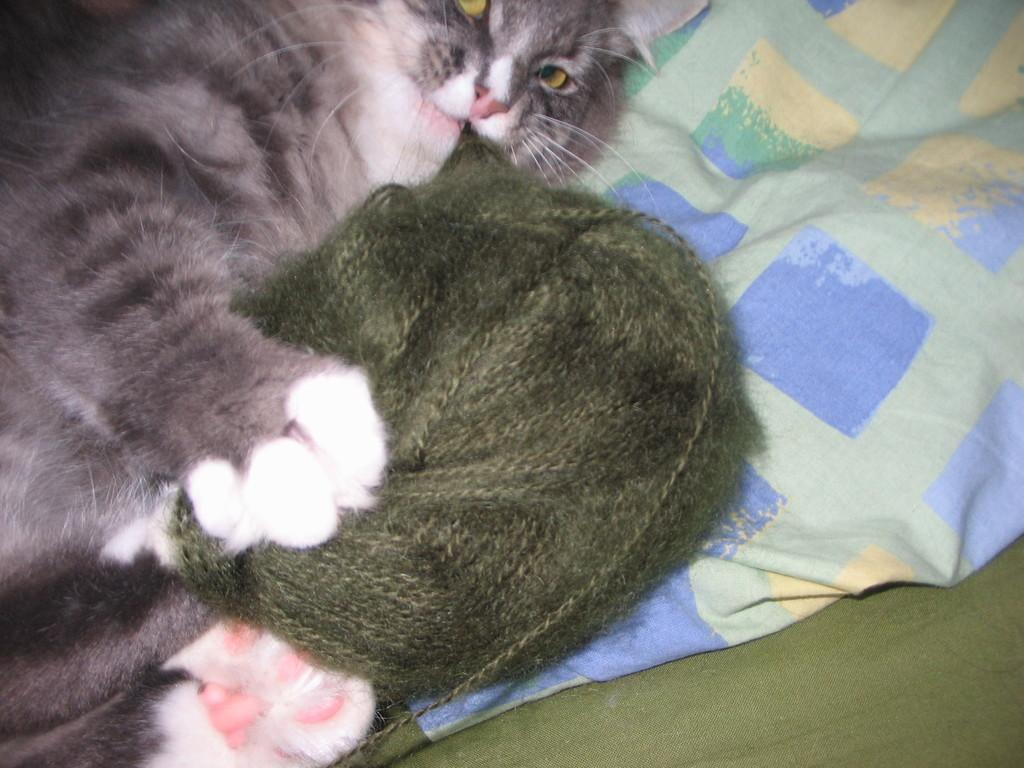What type of animal is lying in the image? There is a cat lying in the image. What object is present near the cat? There is a woolen ball in the image. What else can be seen in the image besides the cat and the woolen ball? There are clothes in the image. What type of metal object is being used by the cat to assert its authority in the image? There is no metal object or indication of authority in the image; it simply shows a cat lying with a woolen ball and clothes nearby. 